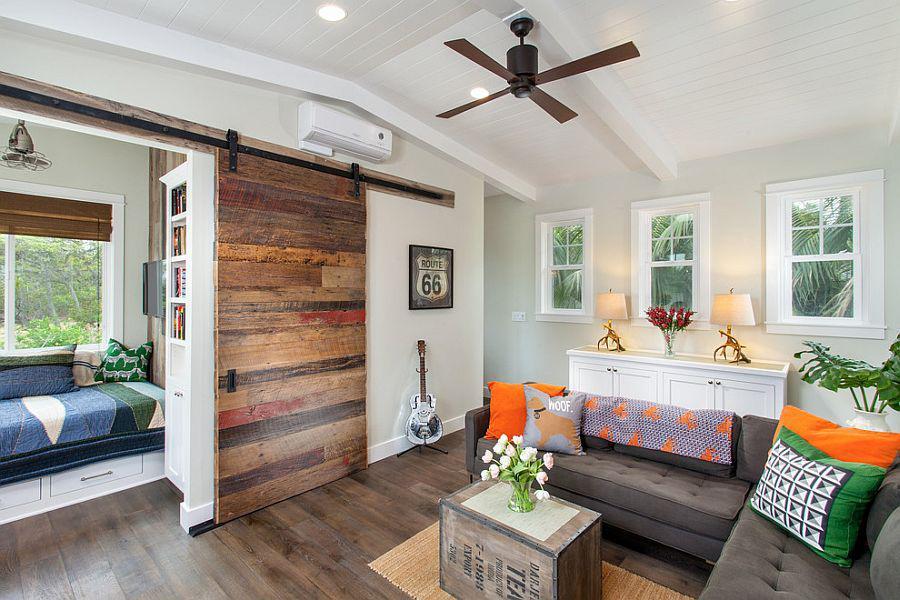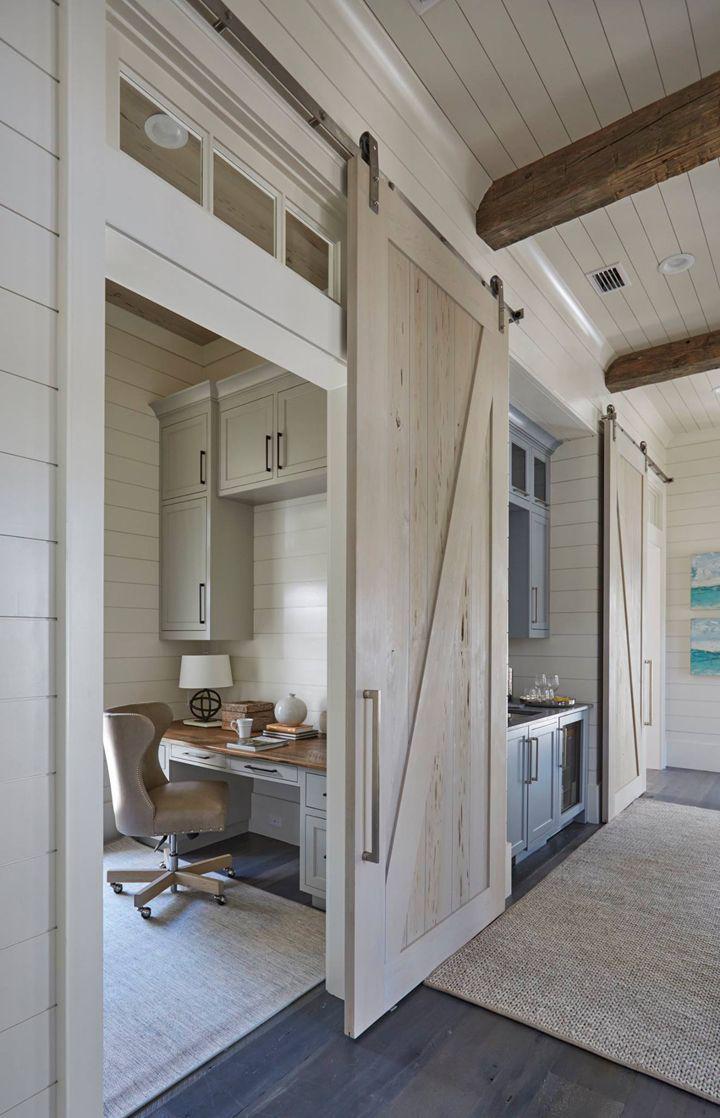The first image is the image on the left, the second image is the image on the right. Examine the images to the left and right. Is the description "In at least one image there is at least one hanging wooden door on a track." accurate? Answer yes or no. Yes. 